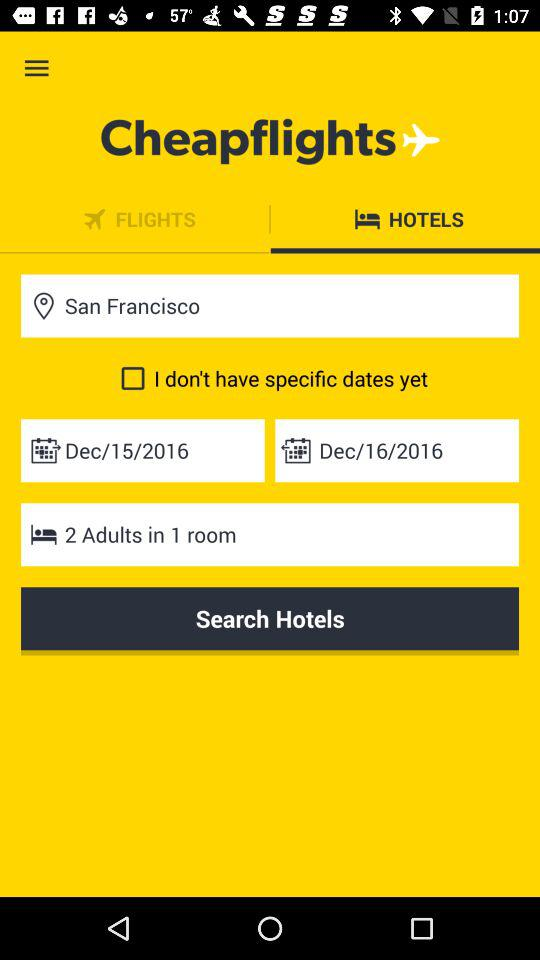What is the check-out date?
When the provided information is insufficient, respond with <no answer>. <no answer> 